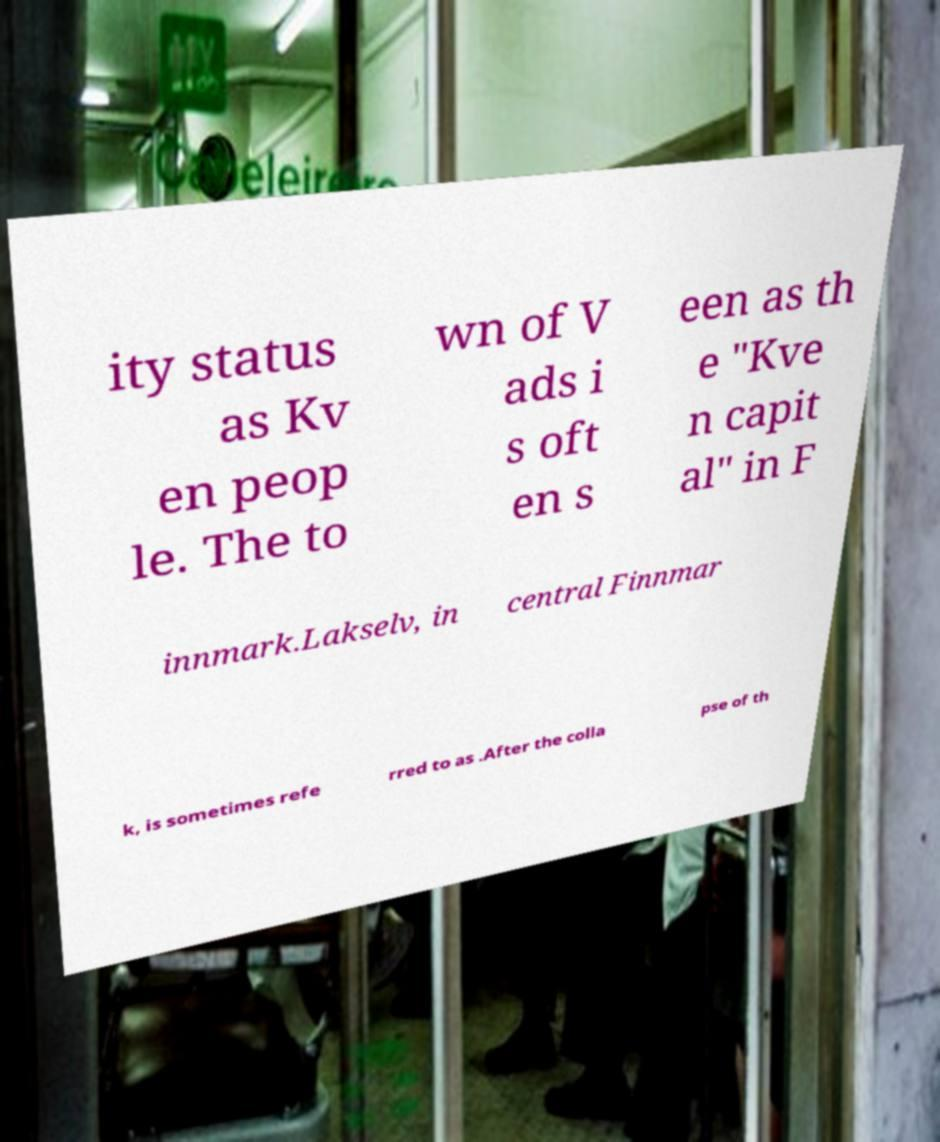I need the written content from this picture converted into text. Can you do that? ity status as Kv en peop le. The to wn of V ads i s oft en s een as th e "Kve n capit al" in F innmark.Lakselv, in central Finnmar k, is sometimes refe rred to as .After the colla pse of th 